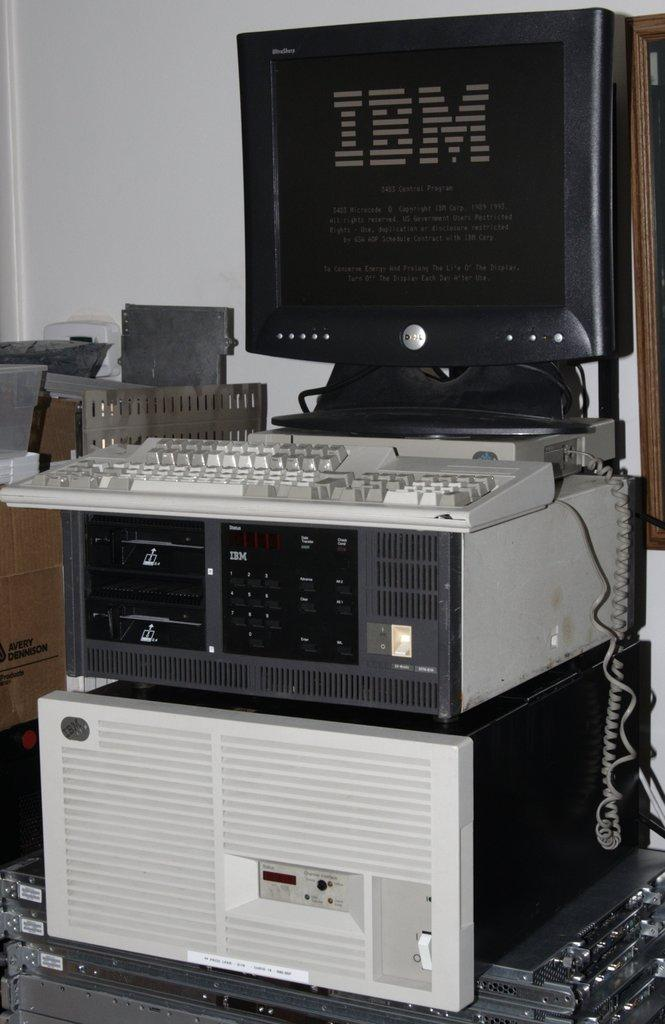Provide a one-sentence caption for the provided image. An IBM computer sitting in a rack with keyboard. 